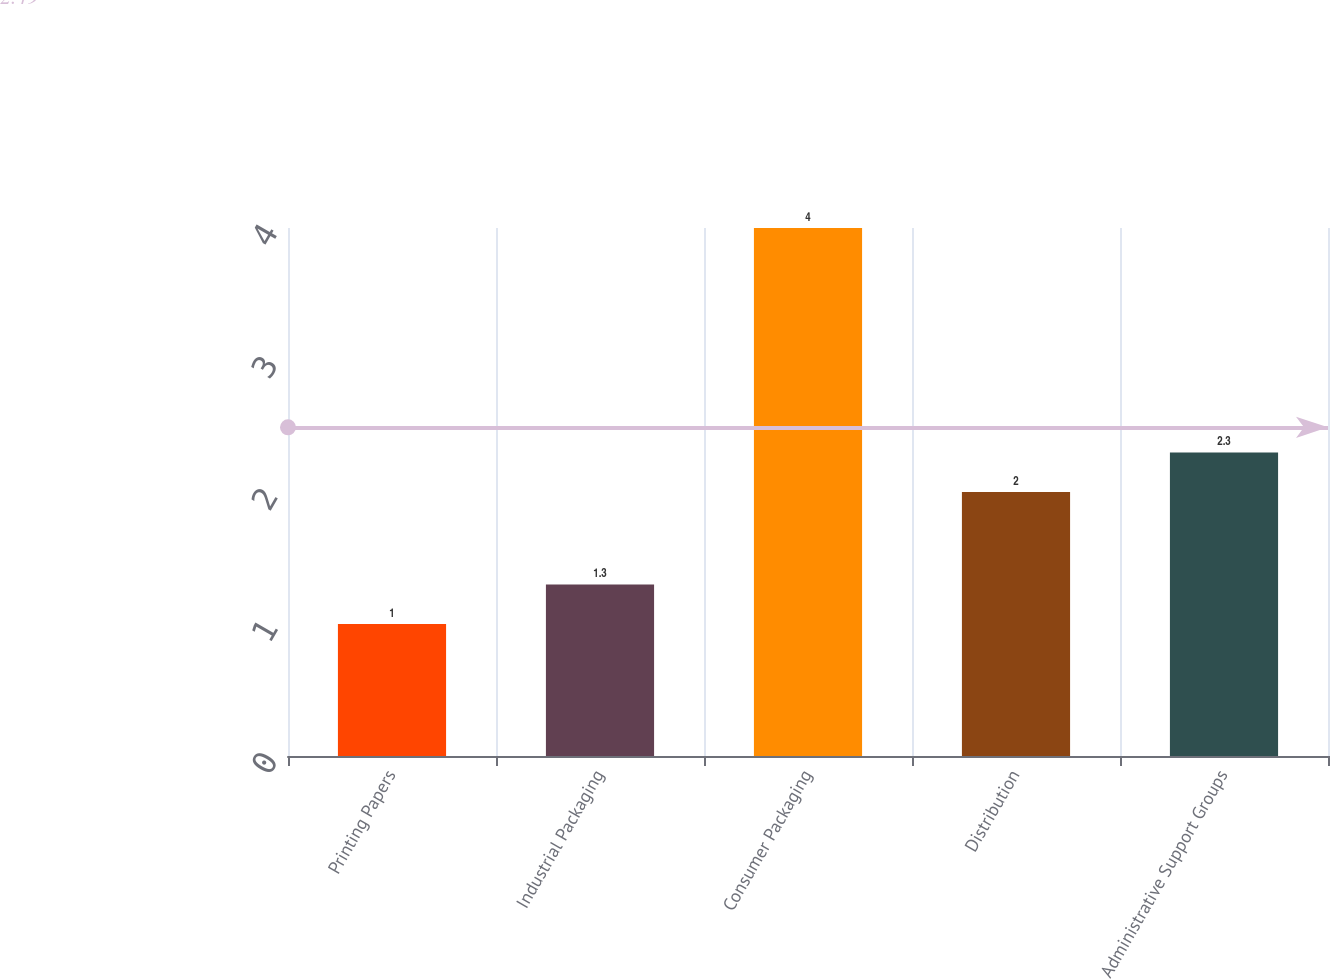Convert chart. <chart><loc_0><loc_0><loc_500><loc_500><bar_chart><fcel>Printing Papers<fcel>Industrial Packaging<fcel>Consumer Packaging<fcel>Distribution<fcel>Administrative Support Groups<nl><fcel>1<fcel>1.3<fcel>4<fcel>2<fcel>2.3<nl></chart> 